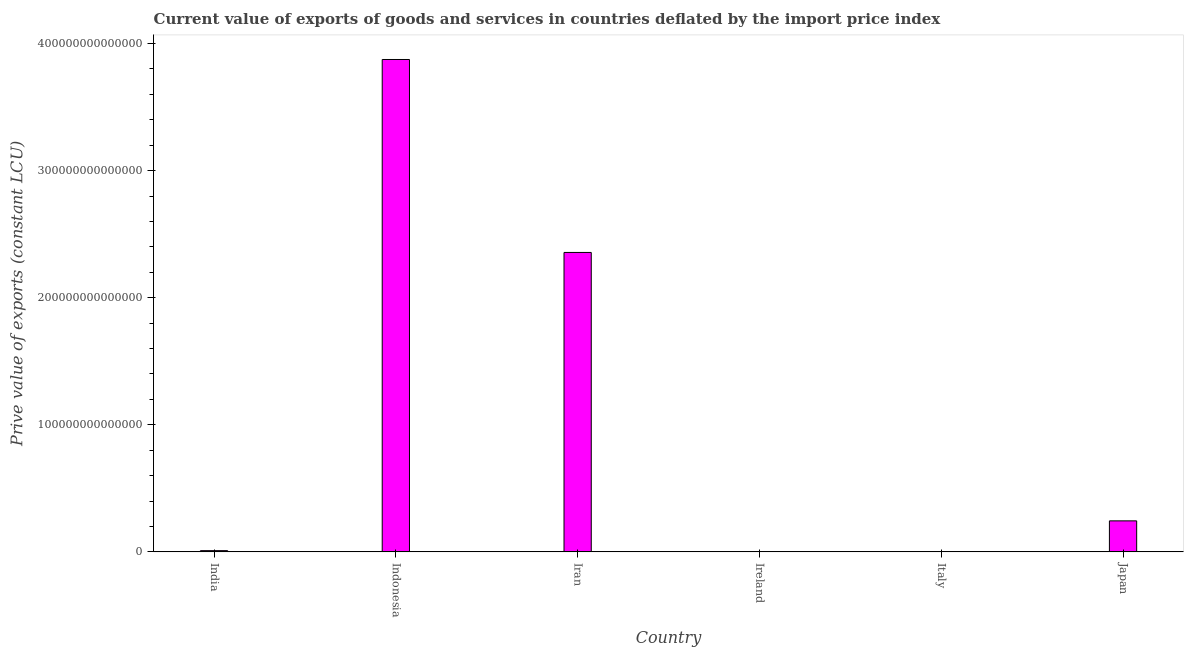Does the graph contain grids?
Your response must be concise. No. What is the title of the graph?
Provide a short and direct response. Current value of exports of goods and services in countries deflated by the import price index. What is the label or title of the X-axis?
Your answer should be compact. Country. What is the label or title of the Y-axis?
Offer a very short reply. Prive value of exports (constant LCU). What is the price value of exports in Italy?
Keep it short and to the point. 1.35e+11. Across all countries, what is the maximum price value of exports?
Offer a terse response. 3.87e+14. Across all countries, what is the minimum price value of exports?
Give a very brief answer. 1.51e+1. In which country was the price value of exports minimum?
Ensure brevity in your answer.  Ireland. What is the sum of the price value of exports?
Offer a very short reply. 6.48e+14. What is the difference between the price value of exports in Indonesia and Iran?
Keep it short and to the point. 1.52e+14. What is the average price value of exports per country?
Ensure brevity in your answer.  1.08e+14. What is the median price value of exports?
Make the answer very short. 1.27e+13. In how many countries, is the price value of exports greater than 120000000000000 LCU?
Offer a very short reply. 2. What is the ratio of the price value of exports in India to that in Indonesia?
Ensure brevity in your answer.  0. Is the difference between the price value of exports in India and Iran greater than the difference between any two countries?
Make the answer very short. No. What is the difference between the highest and the second highest price value of exports?
Your answer should be compact. 1.52e+14. Is the sum of the price value of exports in Iran and Japan greater than the maximum price value of exports across all countries?
Provide a short and direct response. No. What is the difference between the highest and the lowest price value of exports?
Give a very brief answer. 3.87e+14. How many bars are there?
Your response must be concise. 6. How many countries are there in the graph?
Make the answer very short. 6. What is the difference between two consecutive major ticks on the Y-axis?
Make the answer very short. 1.00e+14. What is the Prive value of exports (constant LCU) in India?
Make the answer very short. 9.61e+11. What is the Prive value of exports (constant LCU) of Indonesia?
Offer a terse response. 3.87e+14. What is the Prive value of exports (constant LCU) of Iran?
Offer a very short reply. 2.36e+14. What is the Prive value of exports (constant LCU) of Ireland?
Your answer should be very brief. 1.51e+1. What is the Prive value of exports (constant LCU) in Italy?
Offer a very short reply. 1.35e+11. What is the Prive value of exports (constant LCU) of Japan?
Ensure brevity in your answer.  2.44e+13. What is the difference between the Prive value of exports (constant LCU) in India and Indonesia?
Provide a short and direct response. -3.86e+14. What is the difference between the Prive value of exports (constant LCU) in India and Iran?
Your response must be concise. -2.35e+14. What is the difference between the Prive value of exports (constant LCU) in India and Ireland?
Ensure brevity in your answer.  9.46e+11. What is the difference between the Prive value of exports (constant LCU) in India and Italy?
Your answer should be very brief. 8.27e+11. What is the difference between the Prive value of exports (constant LCU) in India and Japan?
Your answer should be compact. -2.34e+13. What is the difference between the Prive value of exports (constant LCU) in Indonesia and Iran?
Offer a very short reply. 1.52e+14. What is the difference between the Prive value of exports (constant LCU) in Indonesia and Ireland?
Offer a terse response. 3.87e+14. What is the difference between the Prive value of exports (constant LCU) in Indonesia and Italy?
Your response must be concise. 3.87e+14. What is the difference between the Prive value of exports (constant LCU) in Indonesia and Japan?
Keep it short and to the point. 3.63e+14. What is the difference between the Prive value of exports (constant LCU) in Iran and Ireland?
Your answer should be compact. 2.36e+14. What is the difference between the Prive value of exports (constant LCU) in Iran and Italy?
Offer a very short reply. 2.35e+14. What is the difference between the Prive value of exports (constant LCU) in Iran and Japan?
Your answer should be compact. 2.11e+14. What is the difference between the Prive value of exports (constant LCU) in Ireland and Italy?
Offer a terse response. -1.20e+11. What is the difference between the Prive value of exports (constant LCU) in Ireland and Japan?
Give a very brief answer. -2.44e+13. What is the difference between the Prive value of exports (constant LCU) in Italy and Japan?
Ensure brevity in your answer.  -2.43e+13. What is the ratio of the Prive value of exports (constant LCU) in India to that in Indonesia?
Offer a terse response. 0. What is the ratio of the Prive value of exports (constant LCU) in India to that in Iran?
Your answer should be compact. 0. What is the ratio of the Prive value of exports (constant LCU) in India to that in Ireland?
Your answer should be very brief. 63.6. What is the ratio of the Prive value of exports (constant LCU) in India to that in Italy?
Your response must be concise. 7.14. What is the ratio of the Prive value of exports (constant LCU) in India to that in Japan?
Keep it short and to the point. 0.04. What is the ratio of the Prive value of exports (constant LCU) in Indonesia to that in Iran?
Ensure brevity in your answer.  1.64. What is the ratio of the Prive value of exports (constant LCU) in Indonesia to that in Ireland?
Provide a short and direct response. 2.56e+04. What is the ratio of the Prive value of exports (constant LCU) in Indonesia to that in Italy?
Make the answer very short. 2876.6. What is the ratio of the Prive value of exports (constant LCU) in Indonesia to that in Japan?
Offer a terse response. 15.88. What is the ratio of the Prive value of exports (constant LCU) in Iran to that in Ireland?
Your answer should be very brief. 1.56e+04. What is the ratio of the Prive value of exports (constant LCU) in Iran to that in Italy?
Give a very brief answer. 1749.31. What is the ratio of the Prive value of exports (constant LCU) in Iran to that in Japan?
Offer a very short reply. 9.66. What is the ratio of the Prive value of exports (constant LCU) in Ireland to that in Italy?
Your answer should be compact. 0.11. What is the ratio of the Prive value of exports (constant LCU) in Ireland to that in Japan?
Your response must be concise. 0. What is the ratio of the Prive value of exports (constant LCU) in Italy to that in Japan?
Provide a short and direct response. 0.01. 